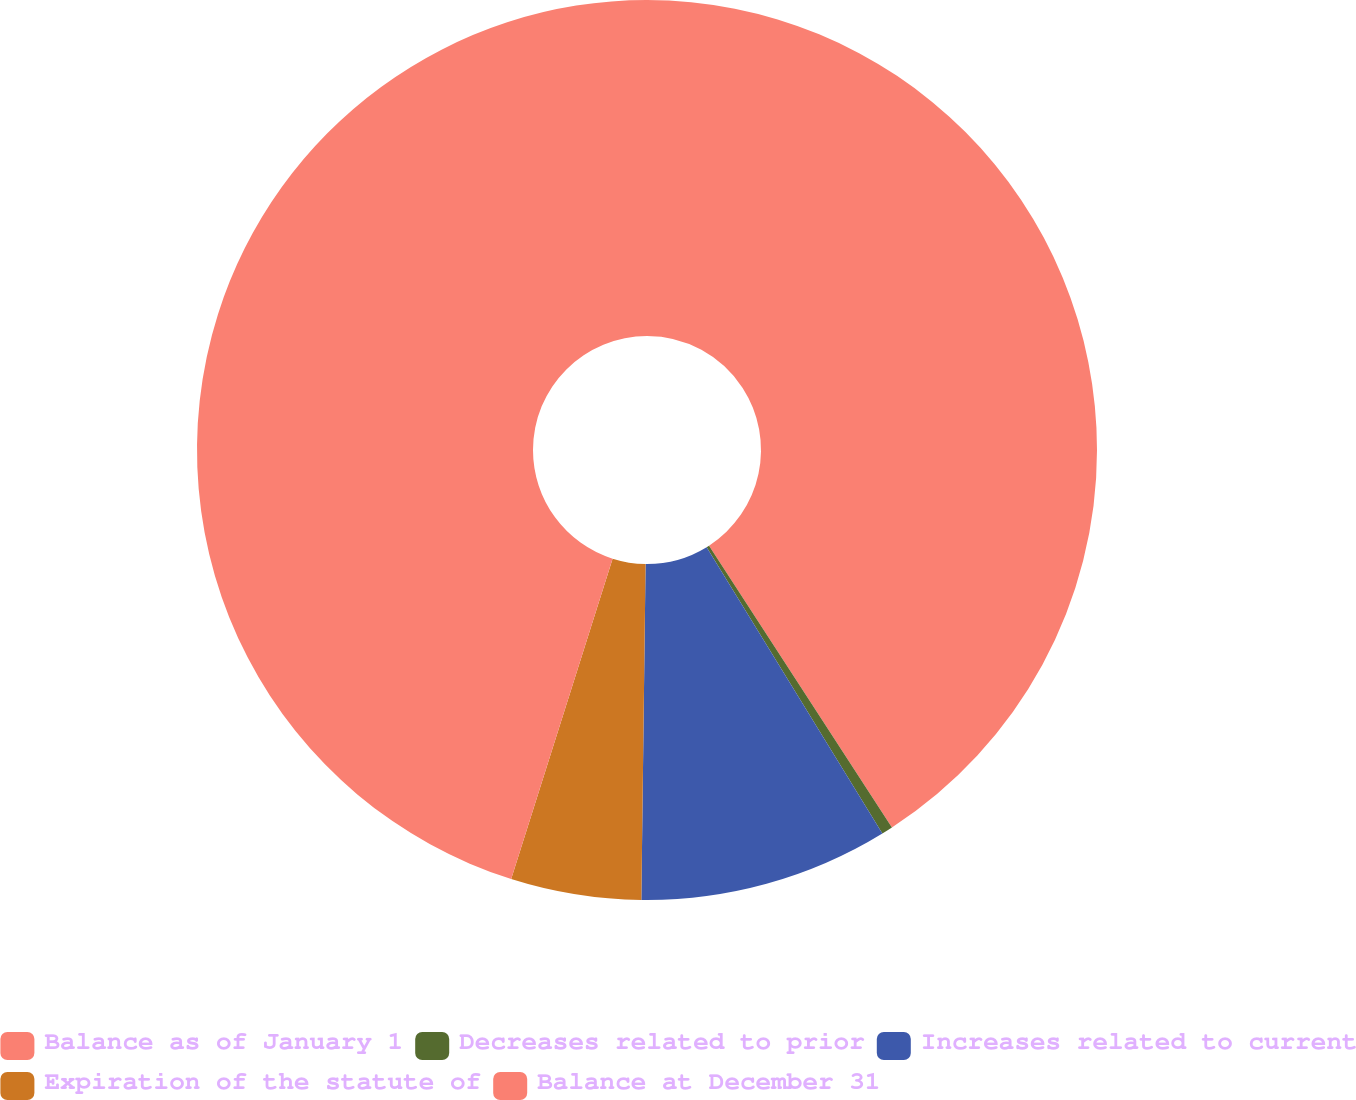Convert chart. <chart><loc_0><loc_0><loc_500><loc_500><pie_chart><fcel>Balance as of January 1<fcel>Decreases related to prior<fcel>Increases related to current<fcel>Expiration of the statute of<fcel>Balance at December 31<nl><fcel>40.84%<fcel>0.4%<fcel>8.96%<fcel>4.68%<fcel>45.12%<nl></chart> 